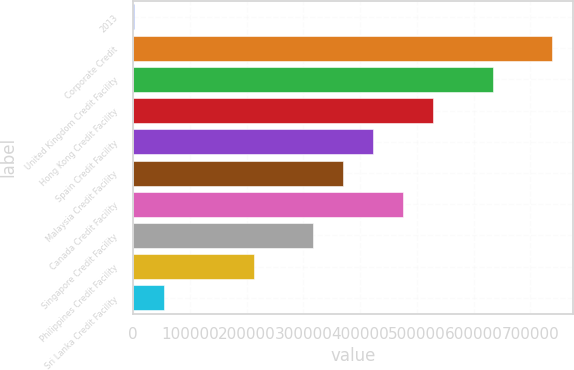Convert chart. <chart><loc_0><loc_0><loc_500><loc_500><bar_chart><fcel>2013<fcel>Corporate Credit<fcel>United Kingdom Credit Facility<fcel>Hong Kong Credit Facility<fcel>Spain Credit Facility<fcel>Malaysia Credit Facility<fcel>Canada Credit Facility<fcel>Singapore Credit Facility<fcel>Philippines Credit Facility<fcel>Sri Lanka Credit Facility<nl><fcel>2012<fcel>738922<fcel>633649<fcel>528376<fcel>423103<fcel>370467<fcel>475740<fcel>317830<fcel>212558<fcel>54648.4<nl></chart> 